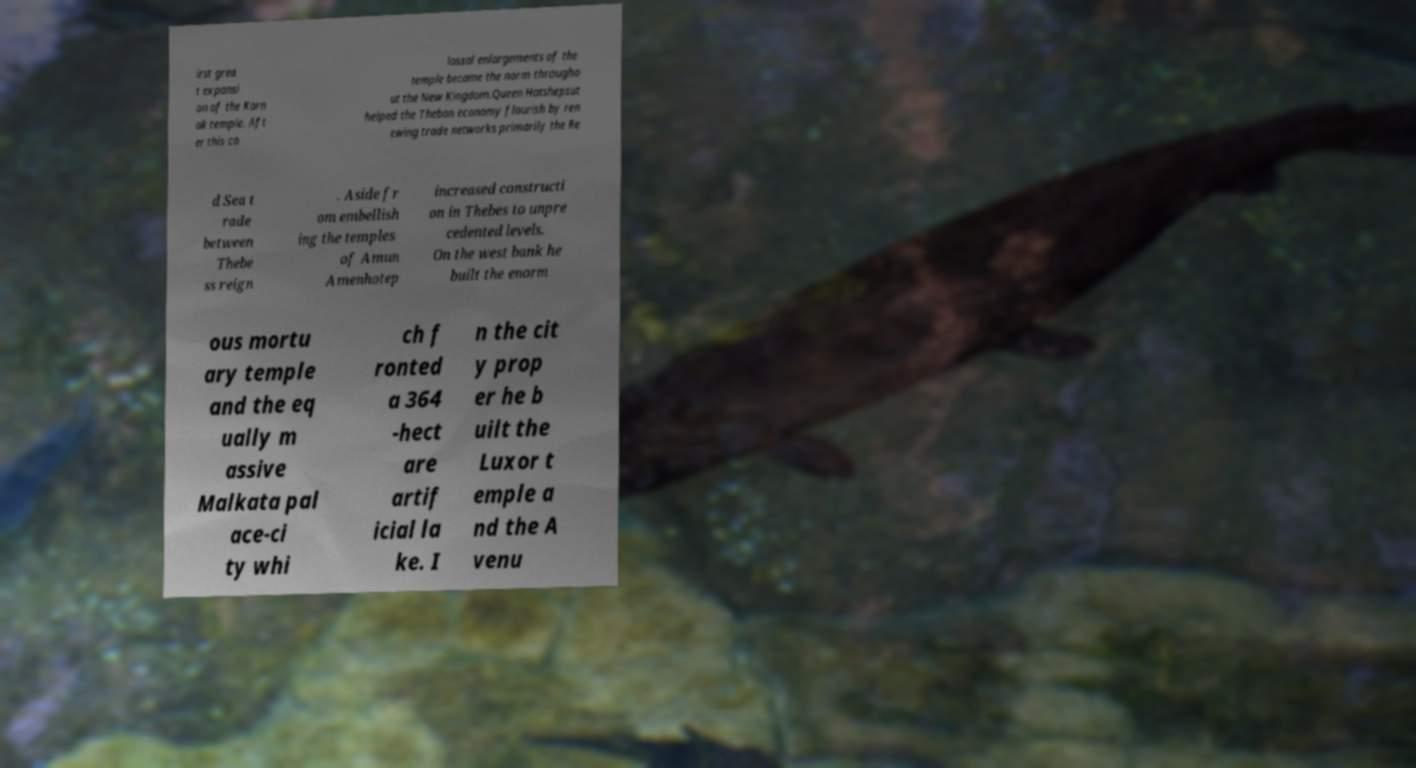For documentation purposes, I need the text within this image transcribed. Could you provide that? irst grea t expansi on of the Karn ak temple. Aft er this co lossal enlargements of the temple became the norm througho ut the New Kingdom.Queen Hatshepsut helped the Theban economy flourish by ren ewing trade networks primarily the Re d Sea t rade between Thebe ss reign . Aside fr om embellish ing the temples of Amun Amenhotep increased constructi on in Thebes to unpre cedented levels. On the west bank he built the enorm ous mortu ary temple and the eq ually m assive Malkata pal ace-ci ty whi ch f ronted a 364 -hect are artif icial la ke. I n the cit y prop er he b uilt the Luxor t emple a nd the A venu 